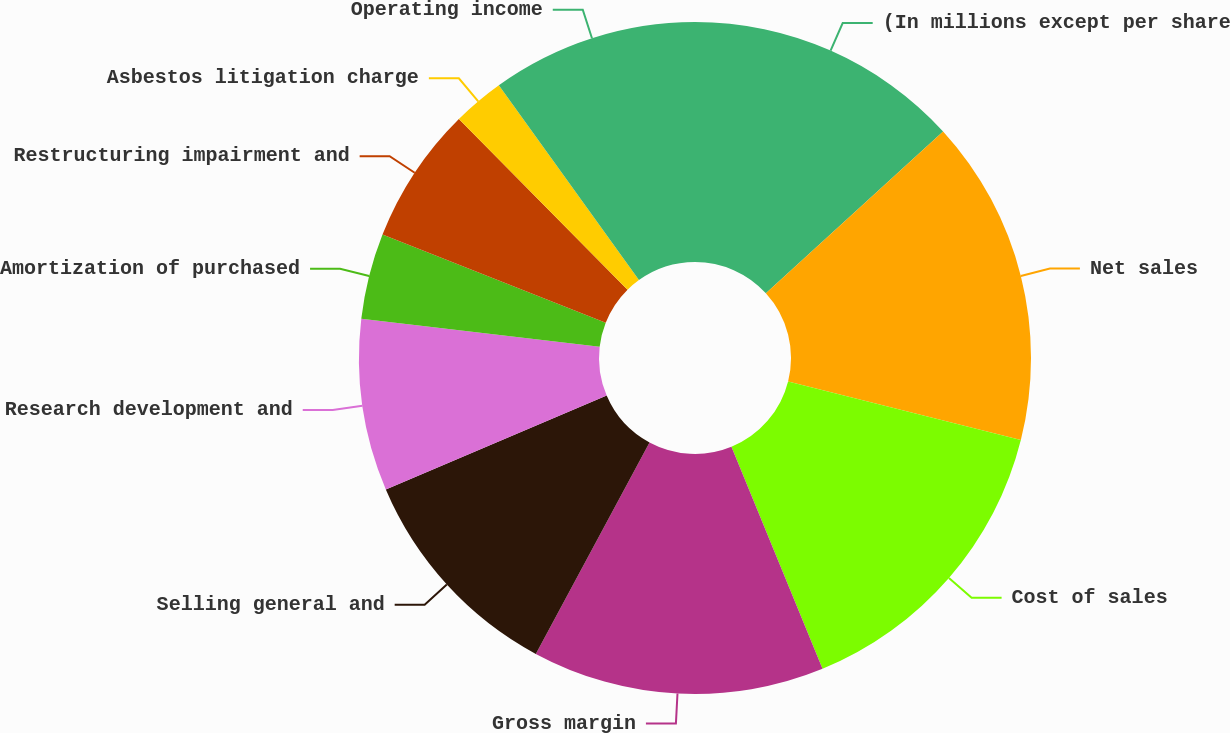Convert chart to OTSL. <chart><loc_0><loc_0><loc_500><loc_500><pie_chart><fcel>(In millions except per share<fcel>Net sales<fcel>Cost of sales<fcel>Gross margin<fcel>Selling general and<fcel>Research development and<fcel>Amortization of purchased<fcel>Restructuring impairment and<fcel>Asbestos litigation charge<fcel>Operating income<nl><fcel>13.22%<fcel>15.7%<fcel>14.88%<fcel>14.05%<fcel>10.74%<fcel>8.26%<fcel>4.13%<fcel>6.61%<fcel>2.48%<fcel>9.92%<nl></chart> 